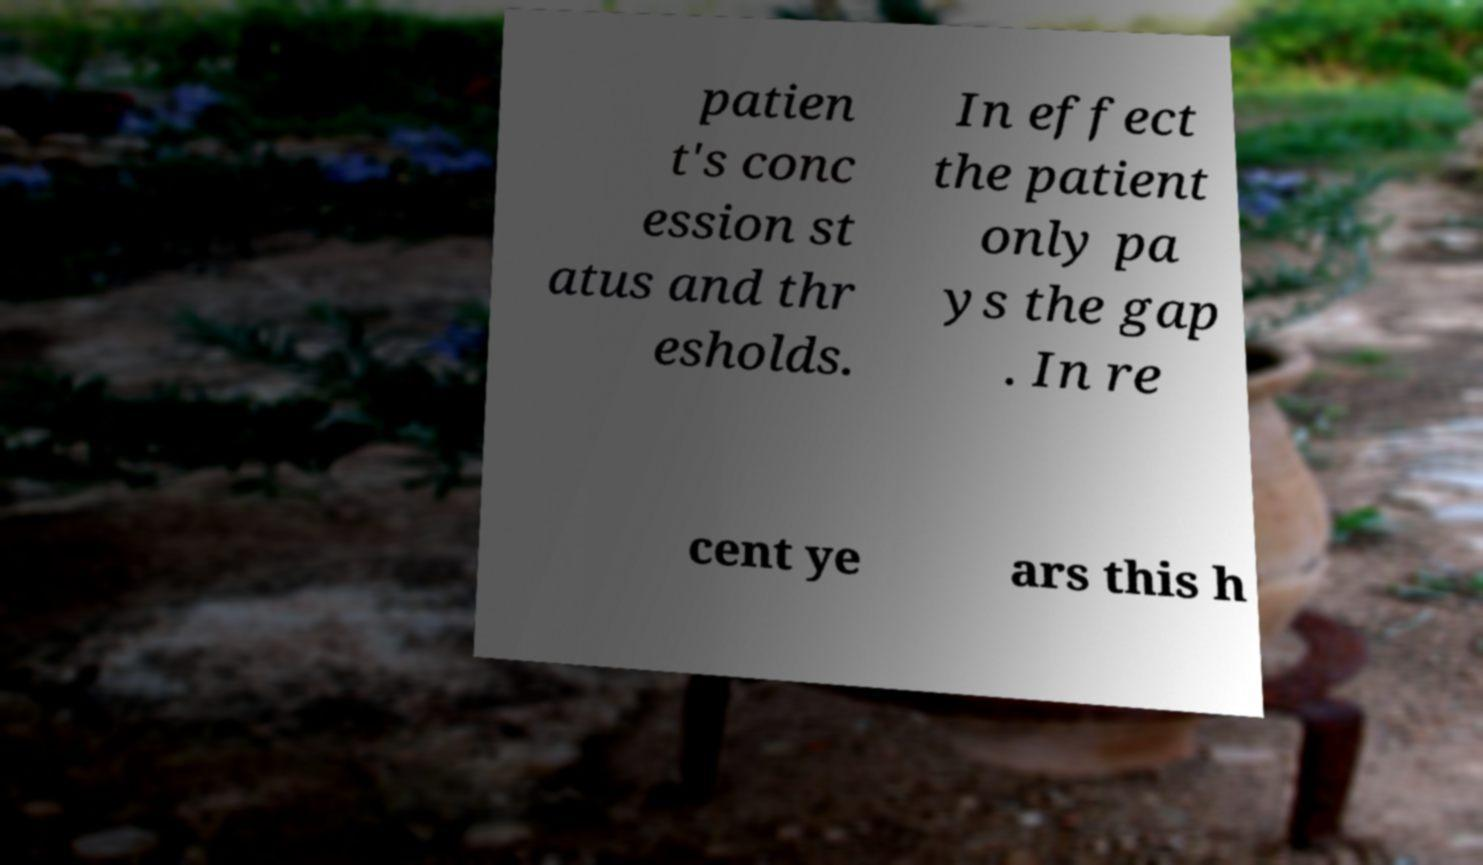For documentation purposes, I need the text within this image transcribed. Could you provide that? patien t's conc ession st atus and thr esholds. In effect the patient only pa ys the gap . In re cent ye ars this h 